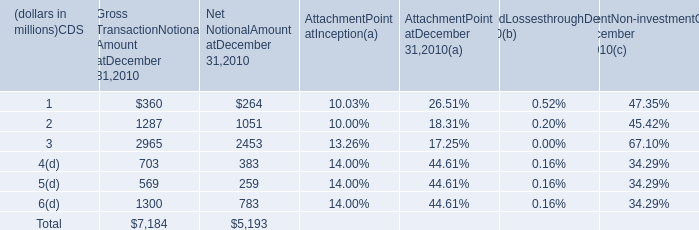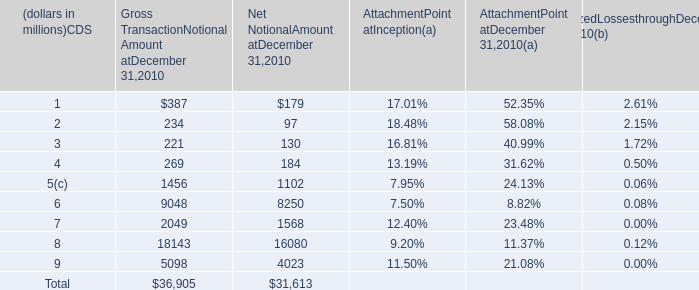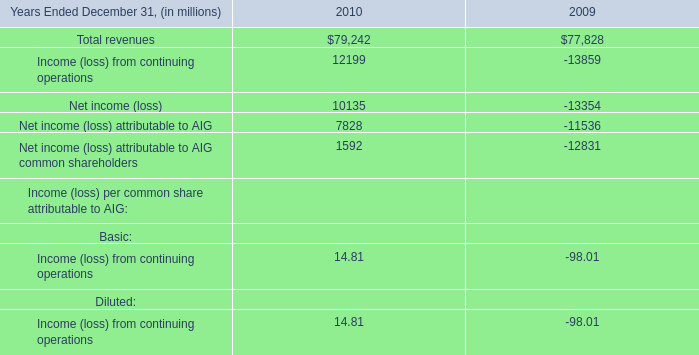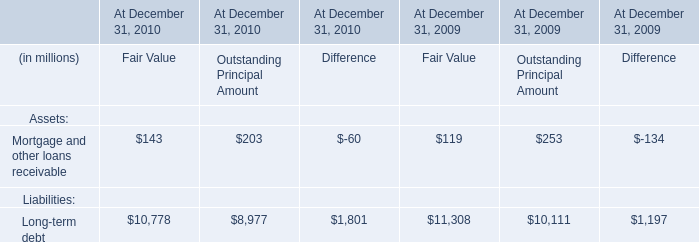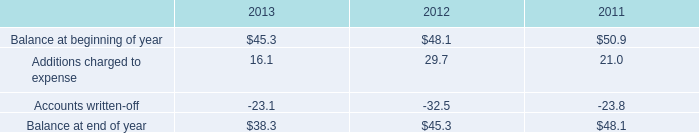What's the total amount of the Net Notional Amount at December 31,2010 in the years where Attachment Point at Inception is greater than 10.00%? (in million) 
Computations: (((((264 + 1051) + 2453) + 383) + 259) + 783)
Answer: 5193.0. 